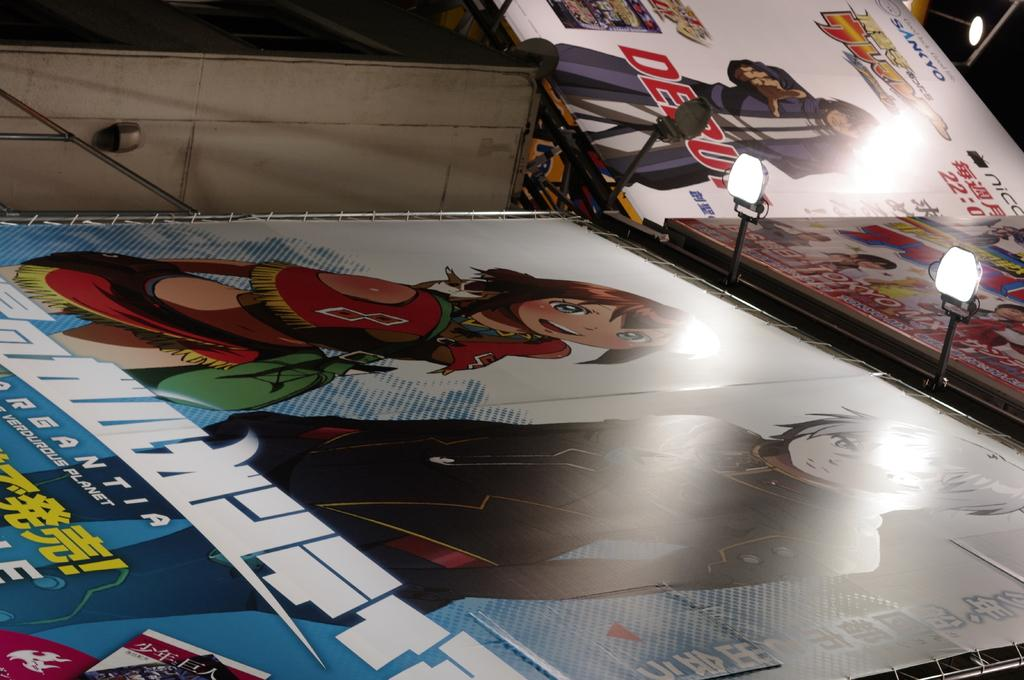What type of images are displayed on the hoardings in the image? The hoardings in the image display cartoons. What can be seen illuminating the area in the image? Lights are visible in the image. What type of structures are present in the image? There are rods in the image. What type of flag is being waved by the cartoon character in the image? There are no cartoon characters or flags present in the image. 